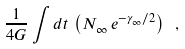<formula> <loc_0><loc_0><loc_500><loc_500>\frac { 1 } { 4 G } \int d t \, \left ( N _ { \infty } \, e ^ { - { \gamma } _ { \infty } / 2 } \right ) \ ,</formula> 